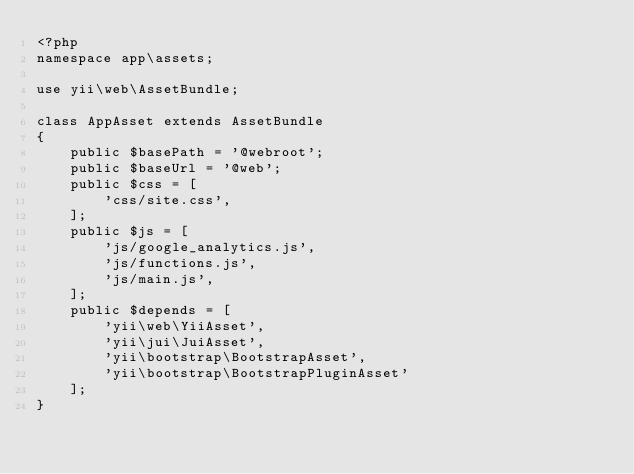<code> <loc_0><loc_0><loc_500><loc_500><_PHP_><?php
namespace app\assets;

use yii\web\AssetBundle;

class AppAsset extends AssetBundle
{
    public $basePath = '@webroot';
    public $baseUrl = '@web';
    public $css = [
        'css/site.css',
    ];
    public $js = [
        'js/google_analytics.js',
        'js/functions.js',
        'js/main.js',
    ];
    public $depends = [
        'yii\web\YiiAsset',
        'yii\jui\JuiAsset',
        'yii\bootstrap\BootstrapAsset',
        'yii\bootstrap\BootstrapPluginAsset'
    ];
}
</code> 